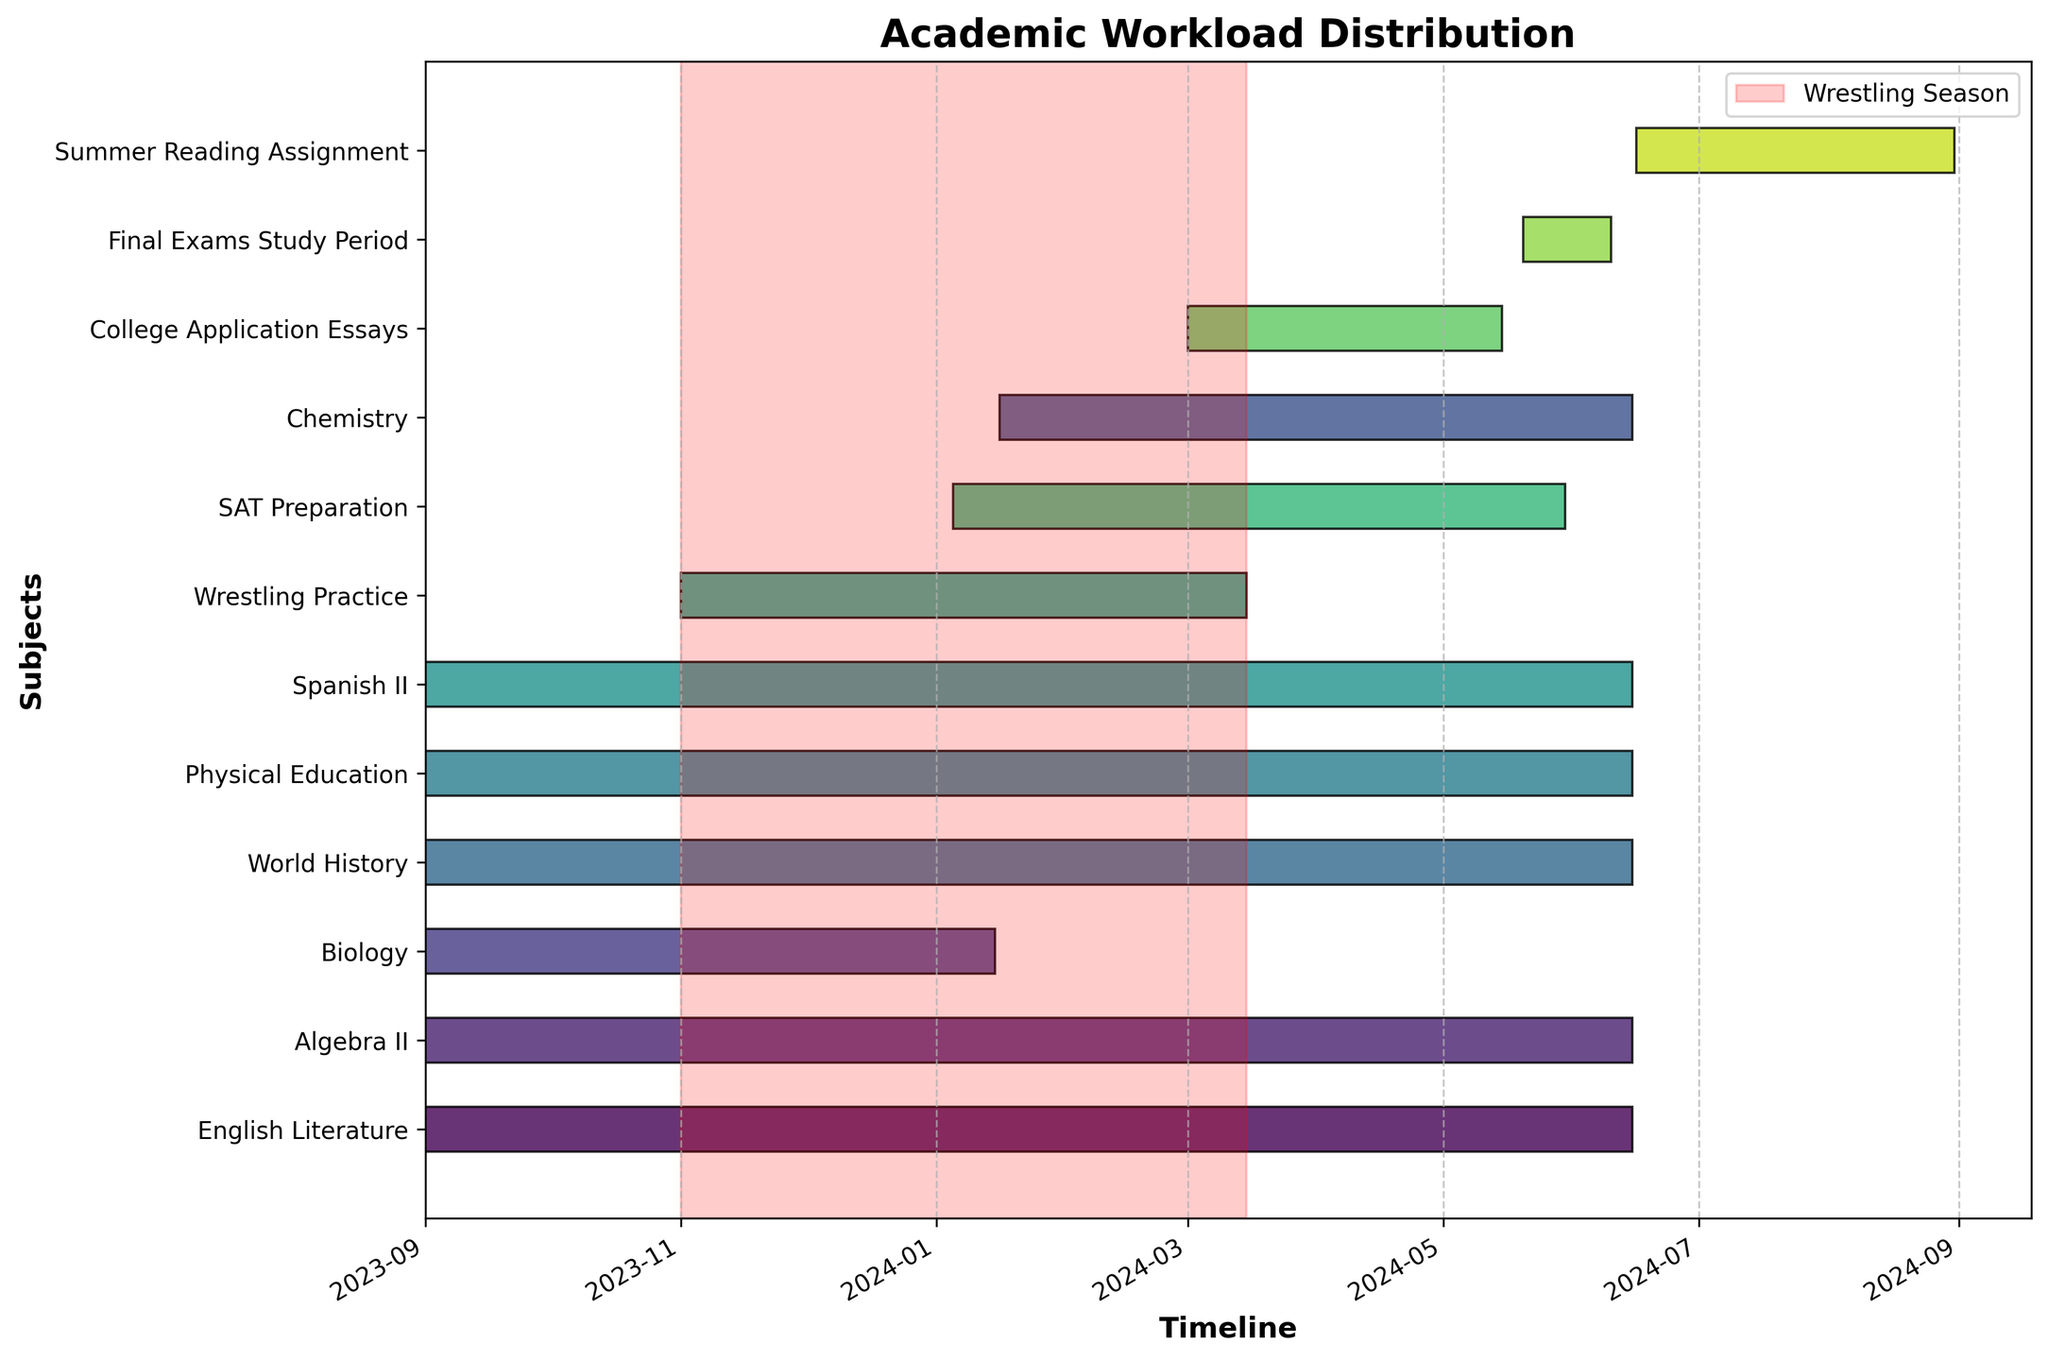Which subject starts on January 16, 2024? The subject which has its timeline bar starting on January 16, 2024, is Chemistry.
Answer: Chemistry Which subjects run throughout the entire school year? The subjects with bars spanning from September 1, 2023, to June 15, 2024, are English Literature, Algebra II, World History, Physical Education, and Spanish II.
Answer: English Literature, Algebra II, World History, Physical Education, Spanish II How long is the wrestling practice period? Wrestling Practice starts on November 1, 2023, and ends on March 15, 2024. The duration can be calculated by counting the days between these dates.
Answer: Approximately 4.5 months Which activity has the shortest duration? By comparing the lengths of the bars, College Application Essays span from March 1, 2024, to May 15, 2024, which seems to be the shortest duration.
Answer: College Application Essays How many subjects overlap with the wrestling practice period? Visualizing the period of Wrestling Practice from November 1, 2023, to March 15, 2024, and checking how many other bars intersect this interval shows overlaps with English Literature, Algebra II, Biology, World History, Physical Education, Spanish II, and SAT Preparation.
Answer: 7 Which periods are dedicated to preparation for exams or assignments? The Gantt chart shows SAT Preparation and Final Exams Study Period, as well as College Application Essays and Summer Reading Assignment as periods dedicated to preparation.
Answer: SAT Preparation, Final Exams Study Period, College Application Essays, Summer Reading Assignment When does the period for SAT Preparation start and end relative to the Final Exams Study Period? SAT Preparation starts on January 5, 2024, and ends on May 30, 2024. The Final Exams Study Period starts after SAT Preparation, beginning on May 20, 2024, and ending on June 10, 2024.
Answer: SAT Preparation starts before and ends just after Final Exams Study Period starts Which subject ends just before Chemistry begins? Biology ends on January 15, 2024, which is the day before Chemistry begins on January 16, 2024.
Answer: Biology How does the duration of the Summer Reading Assignment compare to other subjects? The bar for Summer Reading Assignment spans from June 16, 2024, to August 31, 2024, which is roughly 2.5 months. Comparing this duration to the other subjects' bars shows it is shorter relative to those that span the entire school year but longer than activities like College Application Essays or Final Exams Study Period.
Answer: Longer than College Application Essays but shorter than full-year subjects When during the school year does the heaviest workload occur, considering overlapping periods? By visually examining overlapping periods, the heaviest workload seems to occur from January to mid-March when multiple subjects, SAT Preparation, and Wrestling overlap.
Answer: January to mid-March 